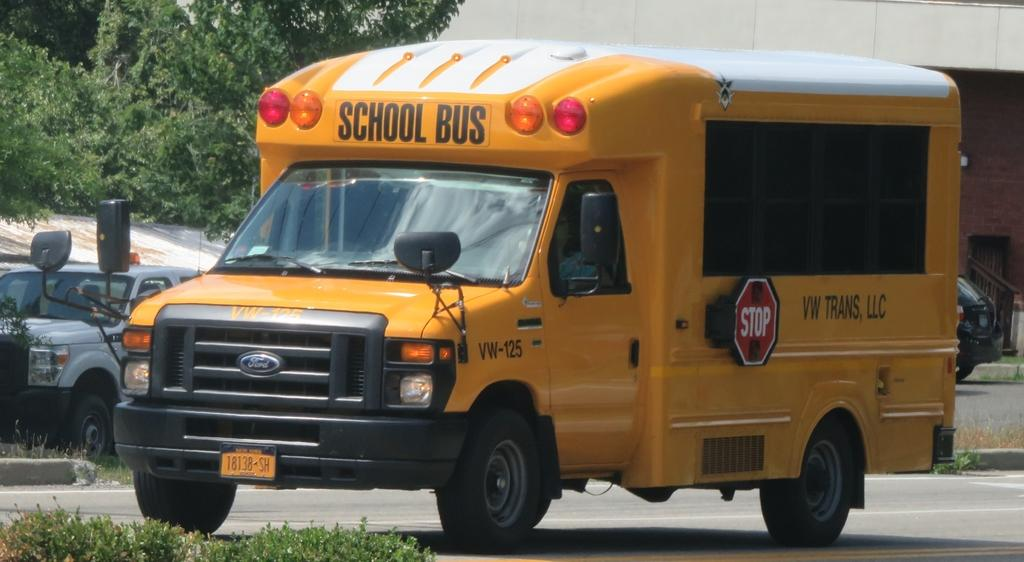What types of objects are on the ground in the image? There are vehicles on the ground in the image. What other elements can be seen in the image besides the vehicles? There are plants, grass, a building with a railing, and trees in the image. What type of coach can be seen interacting with the yam in the image? There is no coach or yam present in the image. What kind of creature is depicted in the image? There is no creature depicted in the image; the main subjects are vehicles, plants, grass, a building with a railing, and trees. 